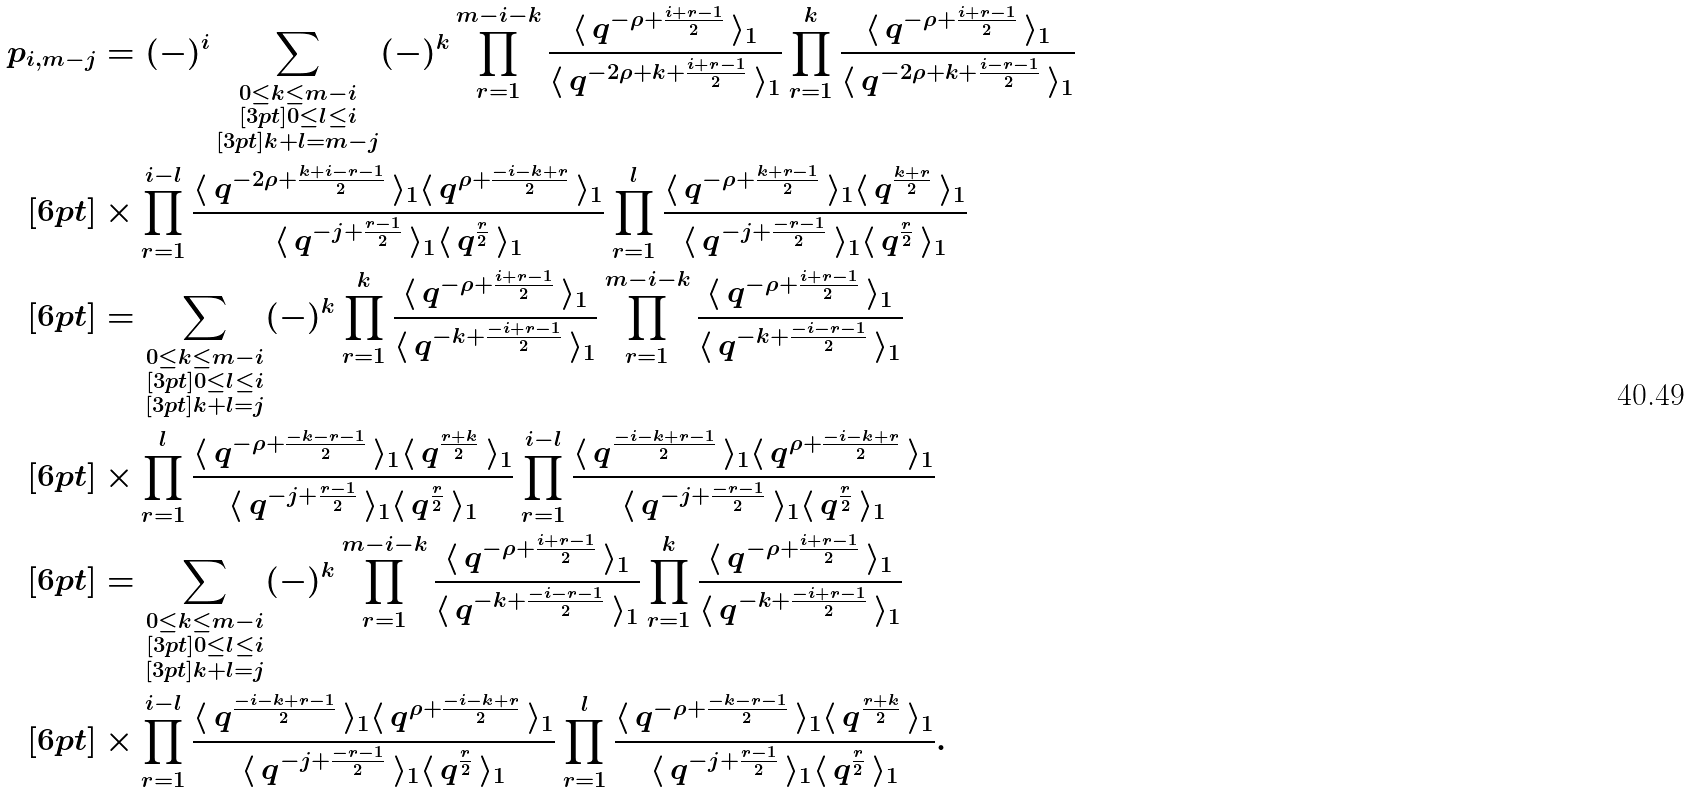Convert formula to latex. <formula><loc_0><loc_0><loc_500><loc_500>p _ { i , m - j } & = ( - ) ^ { i } \sum _ { \substack { 0 \leq k \leq m - i \\ [ 3 p t ] 0 \leq l \leq i \\ [ 3 p t ] k + l = m - j } } ( - ) ^ { k } \prod _ { r = 1 } ^ { m - i - k } \frac { \langle \, q ^ { - \rho + \frac { i + r - 1 } { 2 } } \, \rangle _ { 1 } } { \langle \, q ^ { - 2 \rho + k + \frac { i + r - 1 } { 2 } } \, \rangle _ { 1 } } \prod _ { r = 1 } ^ { k } \frac { \langle \, q ^ { - \rho + \frac { i + r - 1 } { 2 } } \, \rangle _ { 1 } } { \langle \, q ^ { - 2 \rho + k + \frac { i - r - 1 } { 2 } } \, \rangle _ { 1 } } \\ [ 6 p t ] & \times \prod _ { r = 1 } ^ { i - l } \frac { \langle \, q ^ { - 2 \rho + \frac { k + i - r - 1 } { 2 } } \, \rangle _ { 1 } \langle \, q ^ { \rho + \frac { - i - k + r } { 2 } } \, \rangle _ { 1 } } { \langle \, q ^ { - j + \frac { r - 1 } { 2 } } \, \rangle _ { 1 } \langle \, q ^ { \frac { r } { 2 } } \, \rangle _ { 1 } } \prod _ { r = 1 } ^ { l } \frac { \langle \, q ^ { - \rho + \frac { k + r - 1 } { 2 } } \, \rangle _ { 1 } \langle \, q ^ { \frac { k + r } { 2 } } \, \rangle _ { 1 } } { \langle \, q ^ { - j + \frac { - r - 1 } { 2 } } \, \rangle _ { 1 } \langle \, q ^ { \frac { r } { 2 } } \, \rangle _ { 1 } } \\ [ 6 p t ] & = \sum _ { \substack { 0 \leq k \leq m - i \\ [ 3 p t ] 0 \leq l \leq i \\ [ 3 p t ] k + l = j } } ( - ) ^ { k } \prod _ { r = 1 } ^ { k } \frac { \langle \, q ^ { - \rho + \frac { i + r - 1 } { 2 } } \, \rangle _ { 1 } } { \langle \, q ^ { - k + \frac { - i + r - 1 } { 2 } } \, \rangle _ { 1 } } \prod _ { r = 1 } ^ { m - i - k } \frac { \langle \, q ^ { - \rho + \frac { i + r - 1 } { 2 } } \, \rangle _ { 1 } } { \langle \, q ^ { - k + \frac { - i - r - 1 } { 2 } } \, \rangle _ { 1 } } \\ [ 6 p t ] & \times \prod _ { r = 1 } ^ { l } \frac { \langle \, q ^ { - \rho + \frac { - k - r - 1 } { 2 } } \, \rangle _ { 1 } \langle \, q ^ { \frac { r + k } { 2 } } \, \rangle _ { 1 } } { \langle \, q ^ { - j + \frac { r - 1 } { 2 } } \, \rangle _ { 1 } \langle \, q ^ { \frac { r } { 2 } } \, \rangle _ { 1 } } \prod _ { r = 1 } ^ { i - l } \frac { \langle \, q ^ { \frac { - i - k + r - 1 } { 2 } } \, \rangle _ { 1 } \langle \, q ^ { \rho + \frac { - i - k + r } { 2 } } \, \rangle _ { 1 } } { \langle \, q ^ { - j + \frac { - r - 1 } { 2 } } \, \rangle _ { 1 } \langle \, q ^ { \frac { r } { 2 } } \, \rangle _ { 1 } } \\ [ 6 p t ] & = \sum _ { \substack { 0 \leq k \leq m - i \\ [ 3 p t ] 0 \leq l \leq i \\ [ 3 p t ] k + l = j } } ( - ) ^ { k } \prod _ { r = 1 } ^ { m - i - k } \frac { \langle \, q ^ { - \rho + \frac { i + r - 1 } { 2 } } \, \rangle _ { 1 } } { \langle \, q ^ { - k + \frac { - i - r - 1 } { 2 } } \, \rangle _ { 1 } } \prod _ { r = 1 } ^ { k } \frac { \langle \, q ^ { - \rho + \frac { i + r - 1 } { 2 } } \, \rangle _ { 1 } } { \langle \, q ^ { - k + \frac { - i + r - 1 } { 2 } } \, \rangle _ { 1 } } \\ [ 6 p t ] & \times \prod _ { r = 1 } ^ { i - l } \frac { \langle \, q ^ { \frac { - i - k + r - 1 } { 2 } } \, \rangle _ { 1 } \langle \, q ^ { \rho + \frac { - i - k + r } { 2 } } \, \rangle _ { 1 } } { \langle \, q ^ { - j + \frac { - r - 1 } { 2 } } \, \rangle _ { 1 } \langle \, q ^ { \frac { r } { 2 } } \, \rangle _ { 1 } } \prod _ { r = 1 } ^ { l } \frac { \langle \, q ^ { - \rho + \frac { - k - r - 1 } { 2 } } \, \rangle _ { 1 } \langle \, q ^ { \frac { r + k } { 2 } } \, \rangle _ { 1 } } { \langle \, q ^ { - j + \frac { r - 1 } { 2 } } \, \rangle _ { 1 } \langle \, q ^ { \frac { r } { 2 } } \, \rangle _ { 1 } } .</formula> 